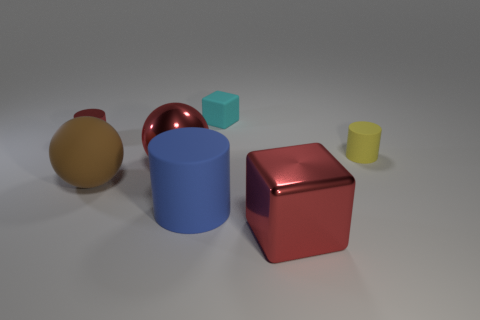There is a large object that is on the right side of the big red metal sphere and behind the large red cube; what is its color?
Give a very brief answer. Blue. Do the big blue object and the large red ball have the same material?
Your answer should be compact. No. What number of large things are either blue cylinders or cyan shiny cylinders?
Provide a succinct answer. 1. Is there anything else that is the same shape as the brown thing?
Your answer should be compact. Yes. What color is the tiny block that is made of the same material as the big brown sphere?
Offer a very short reply. Cyan. There is a rubber cylinder left of the tiny cyan cube; what is its color?
Give a very brief answer. Blue. How many tiny metallic cylinders have the same color as the big metal ball?
Provide a succinct answer. 1. Are there fewer small matte cylinders in front of the large blue thing than blue matte objects that are behind the large brown ball?
Your answer should be compact. No. There is a brown ball; what number of cylinders are on the right side of it?
Your response must be concise. 2. Are there any small red cylinders made of the same material as the tiny cyan cube?
Offer a very short reply. No. 